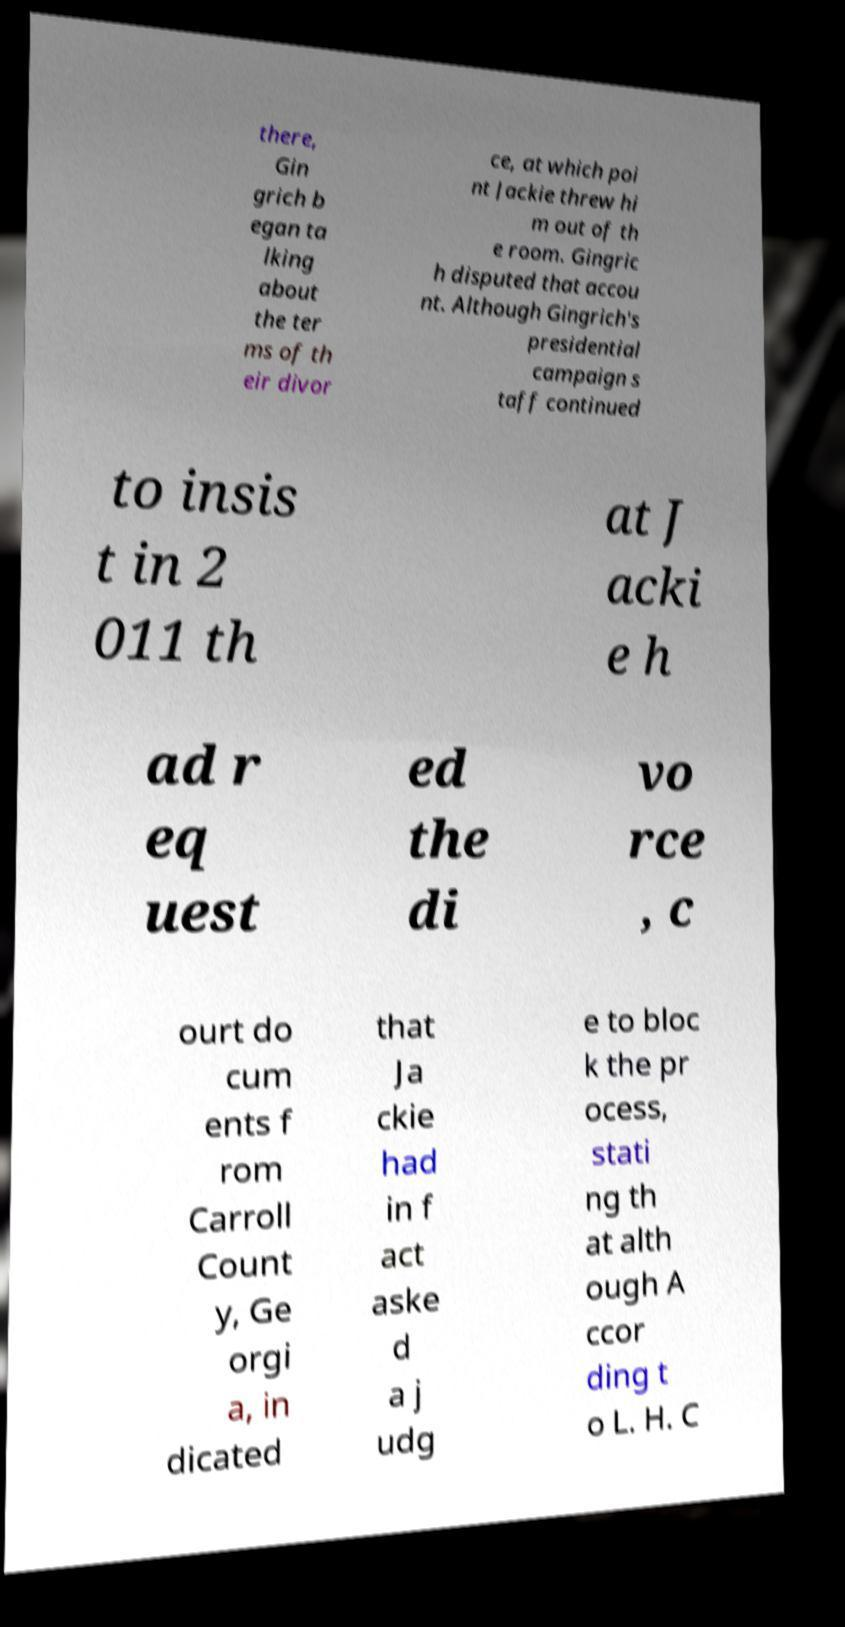I need the written content from this picture converted into text. Can you do that? there, Gin grich b egan ta lking about the ter ms of th eir divor ce, at which poi nt Jackie threw hi m out of th e room. Gingric h disputed that accou nt. Although Gingrich's presidential campaign s taff continued to insis t in 2 011 th at J acki e h ad r eq uest ed the di vo rce , c ourt do cum ents f rom Carroll Count y, Ge orgi a, in dicated that Ja ckie had in f act aske d a j udg e to bloc k the pr ocess, stati ng th at alth ough A ccor ding t o L. H. C 